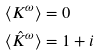Convert formula to latex. <formula><loc_0><loc_0><loc_500><loc_500>\langle K ^ { \omega } \rangle & = 0 \\ \langle \hat { K } ^ { \omega } \rangle & = 1 + i</formula> 